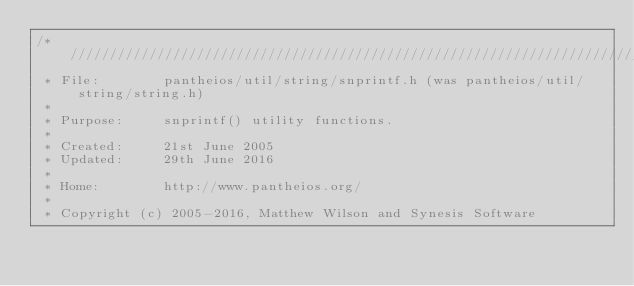<code> <loc_0><loc_0><loc_500><loc_500><_C_>/* /////////////////////////////////////////////////////////////////////////
 * File:        pantheios/util/string/snprintf.h (was pantheios/util/string/string.h)
 *
 * Purpose:     snprintf() utility functions.
 *
 * Created:     21st June 2005
 * Updated:     29th June 2016
 *
 * Home:        http://www.pantheios.org/
 *
 * Copyright (c) 2005-2016, Matthew Wilson and Synesis Software</code> 